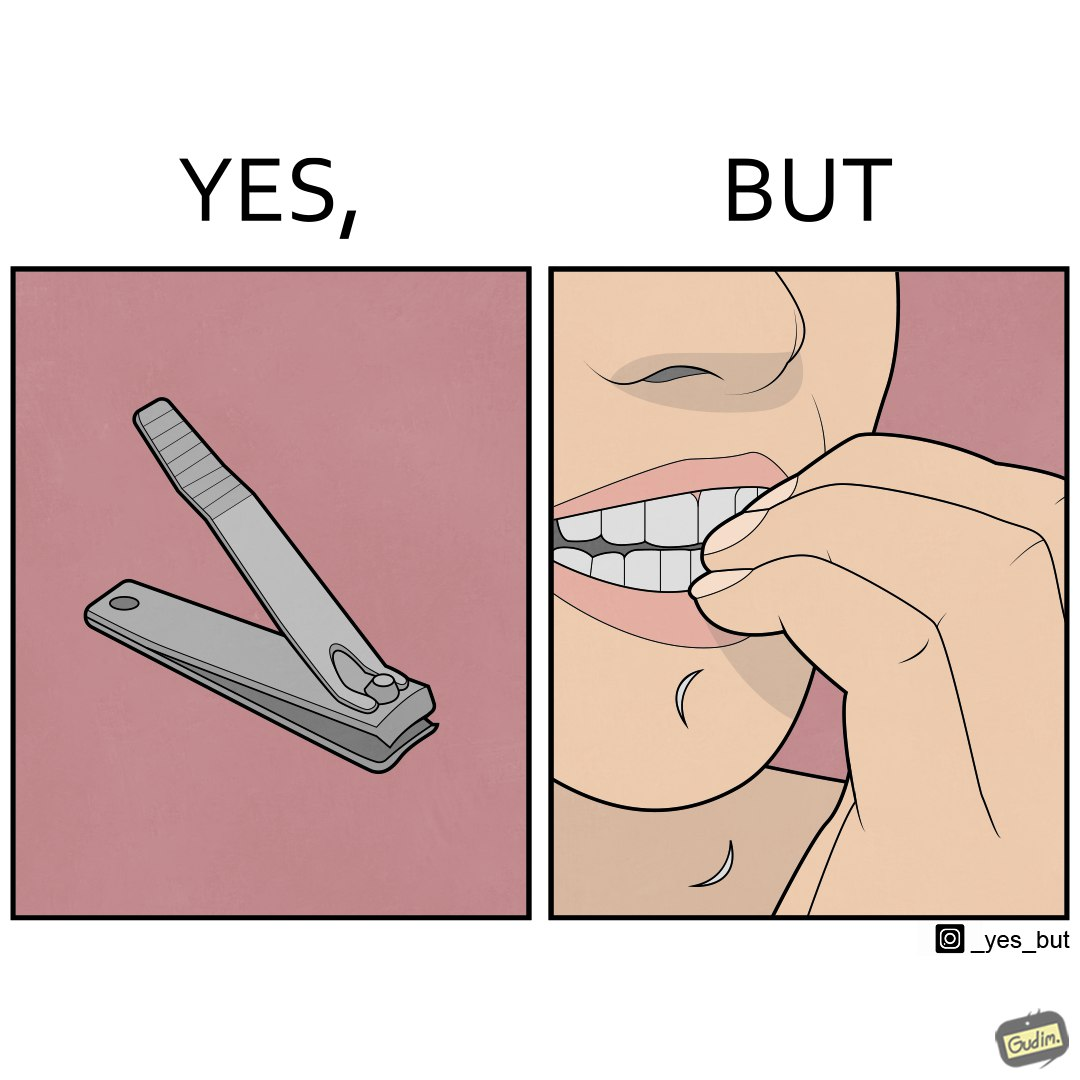Describe the content of this image. The image is ironic, because even after nail clippers are available people prefer biting their nails by teeth 